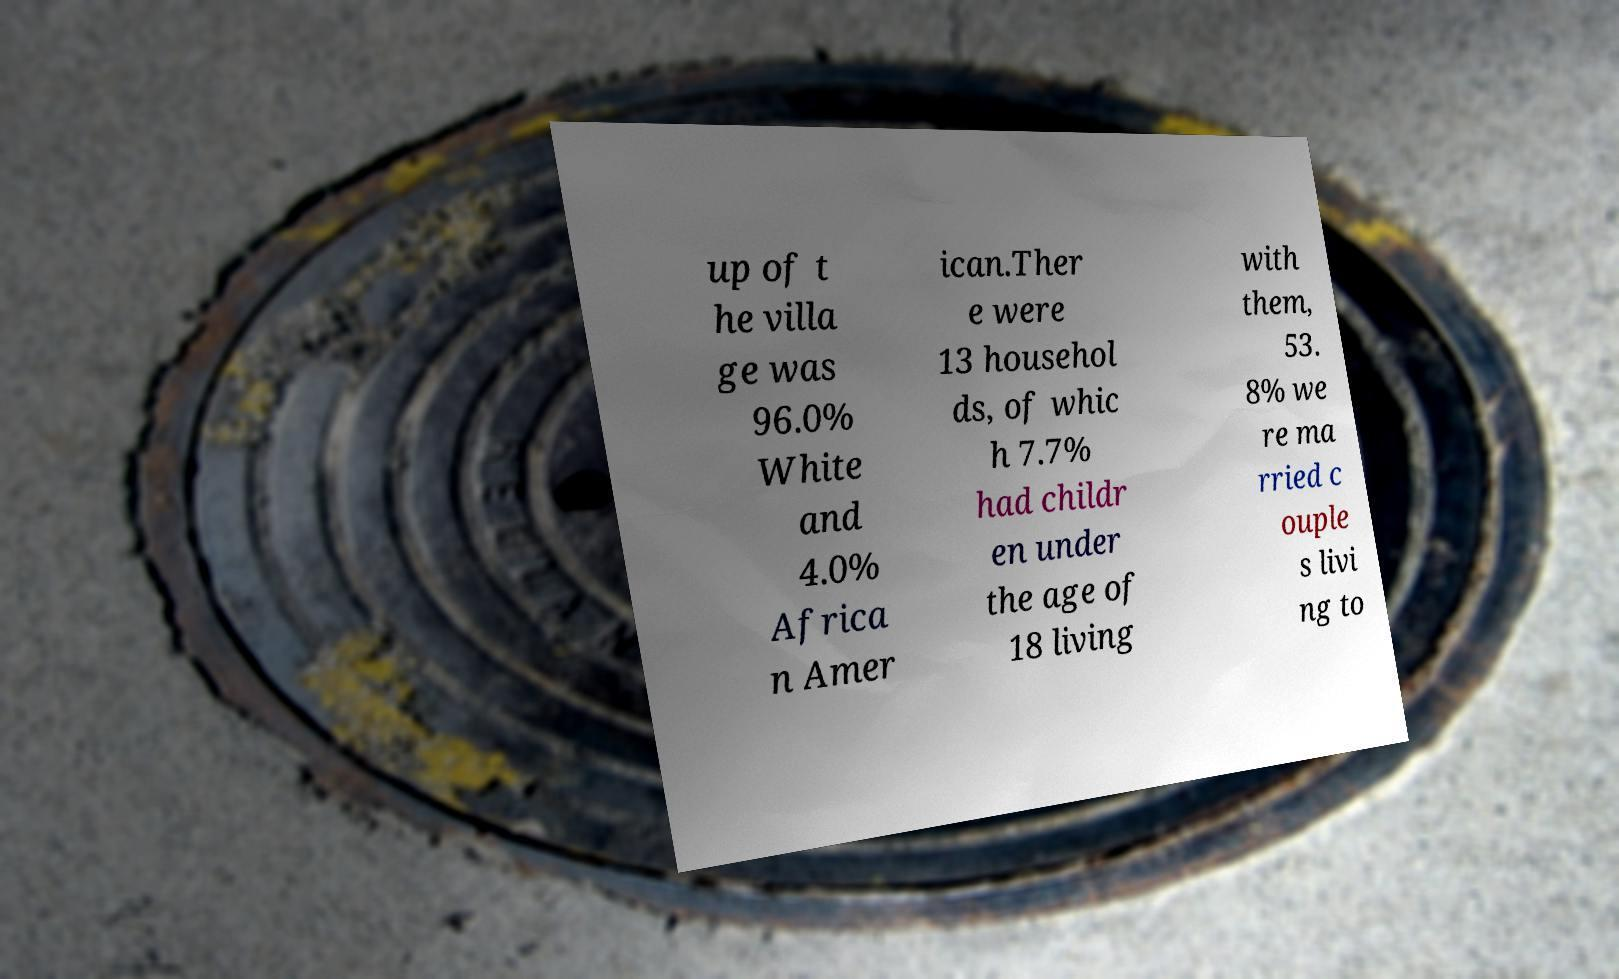Please read and relay the text visible in this image. What does it say? up of t he villa ge was 96.0% White and 4.0% Africa n Amer ican.Ther e were 13 househol ds, of whic h 7.7% had childr en under the age of 18 living with them, 53. 8% we re ma rried c ouple s livi ng to 